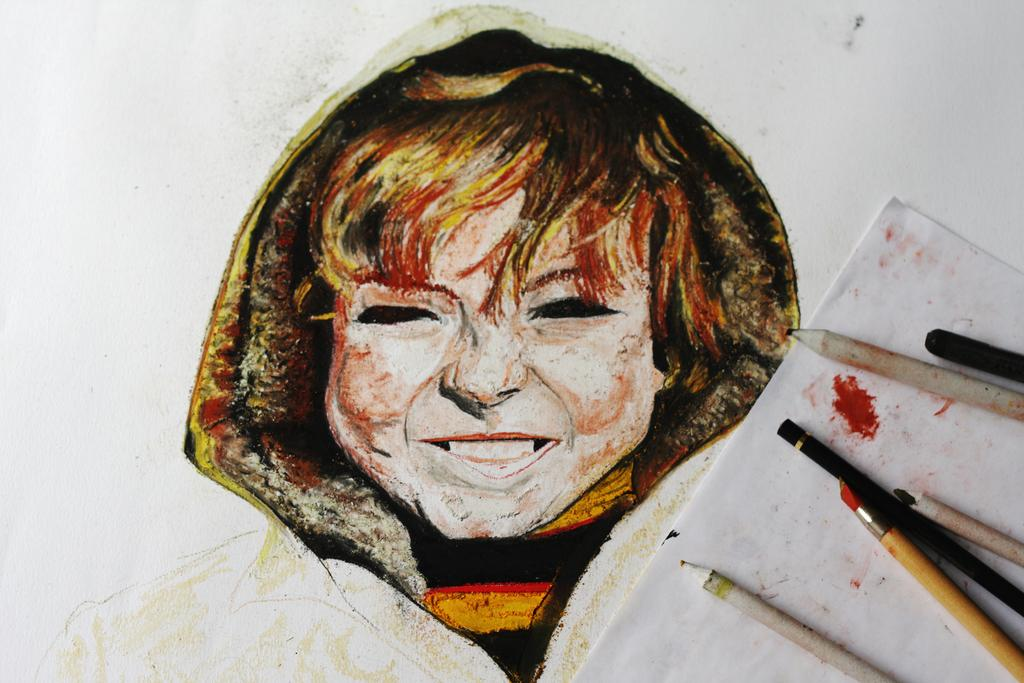What is the main subject of the image? The main subject of the image is a painting of a woman. What can be seen in the image besides the woman? Sketch pencils are placed on paper in the image. How many chickens are present in the image? There are no chickens present in the image; it features a painting of a woman and sketch pencils on paper. What type of powder is used to create the painting in the image? The image is a painting, but there is no information provided about the materials used to create it, so we cannot determine if any powder was used. 